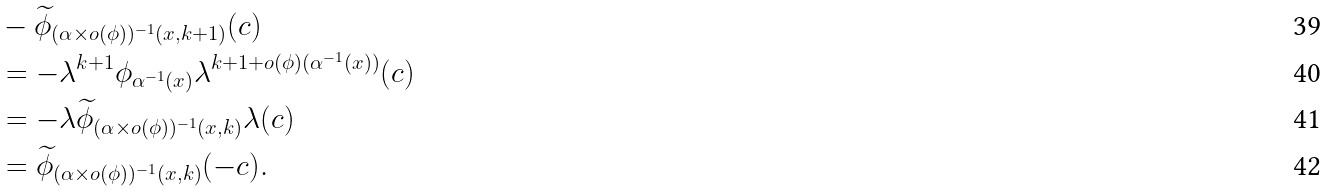<formula> <loc_0><loc_0><loc_500><loc_500>& - \widetilde { \phi } _ { ( \alpha \times o ( \phi ) ) ^ { - 1 } ( x , k + 1 ) } ( c ) \\ & = - \lambda ^ { k + 1 } \phi _ { \alpha ^ { - 1 } ( x ) } \lambda ^ { k + 1 + o ( \phi ) ( \alpha ^ { - 1 } ( x ) ) } ( c ) \\ & = - \lambda \widetilde { \phi } _ { ( \alpha \times o ( \phi ) ) ^ { - 1 } ( x , k ) } \lambda ( c ) \\ & = \widetilde { \phi } _ { ( \alpha \times o ( \phi ) ) ^ { - 1 } ( x , k ) } ( - c ) .</formula> 